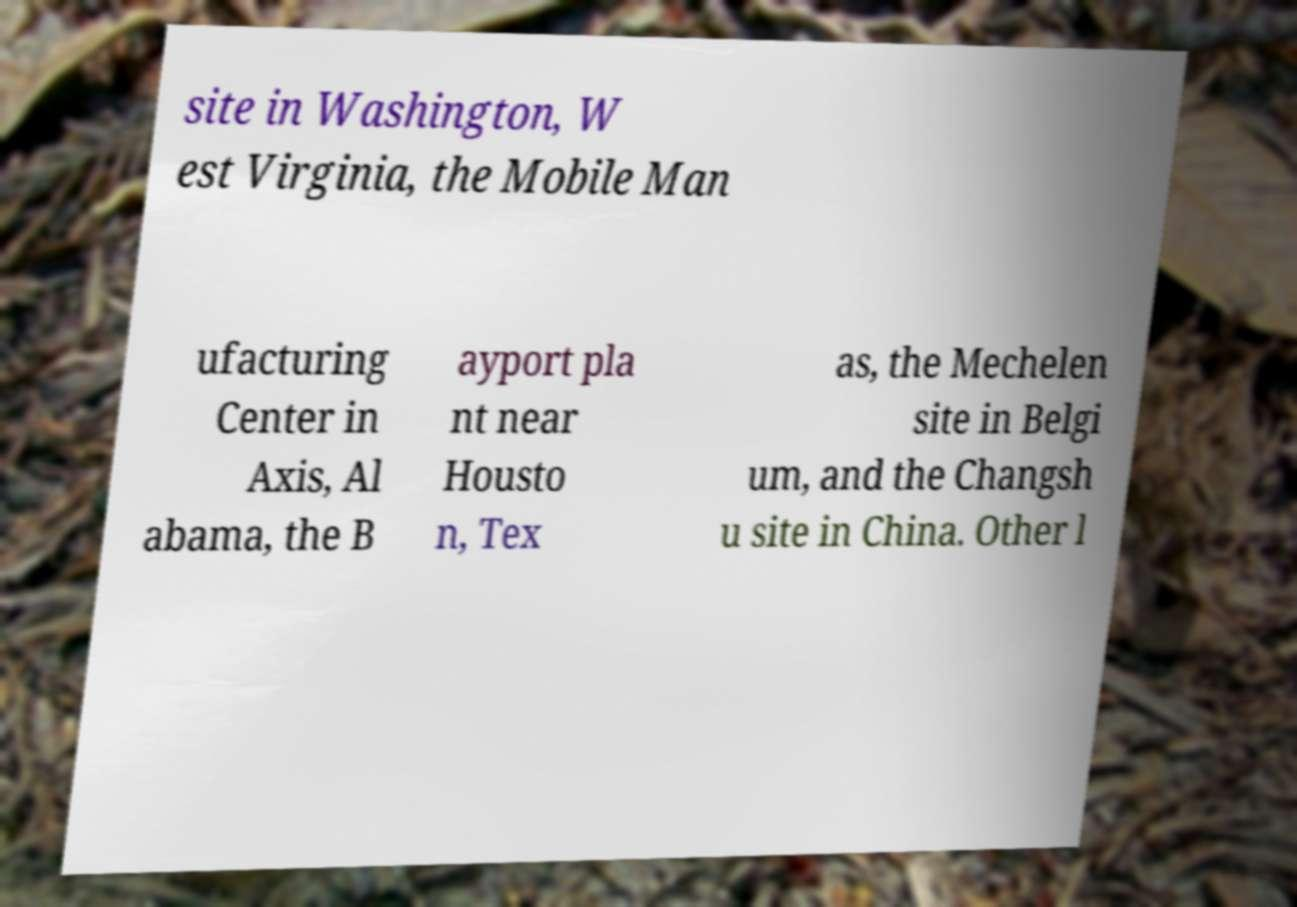Please identify and transcribe the text found in this image. site in Washington, W est Virginia, the Mobile Man ufacturing Center in Axis, Al abama, the B ayport pla nt near Housto n, Tex as, the Mechelen site in Belgi um, and the Changsh u site in China. Other l 